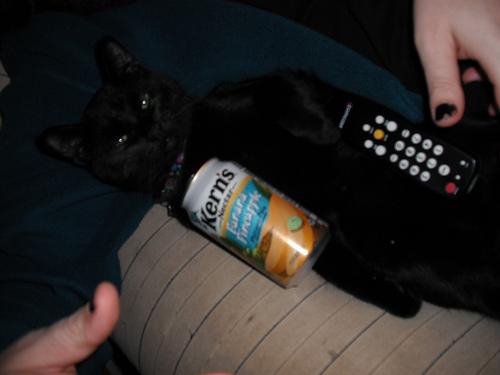What is the cat looking at?
Answer briefly. Camera. What is the large black object in the center?
Short answer required. Cat. Is the cat asleep?
Give a very brief answer. No. What brand is on the can?
Keep it brief. Kern's. Is this a 2 liter bottle?
Answer briefly. No. What type of drink is in the can?
Be succinct. Juice. Is the cat watching TV?
Concise answer only. Yes. Is the woman drinking wine?
Concise answer only. No. What color collar is the cat wearing?
Answer briefly. Black. What is she pouring?
Write a very short answer. Nothing. 